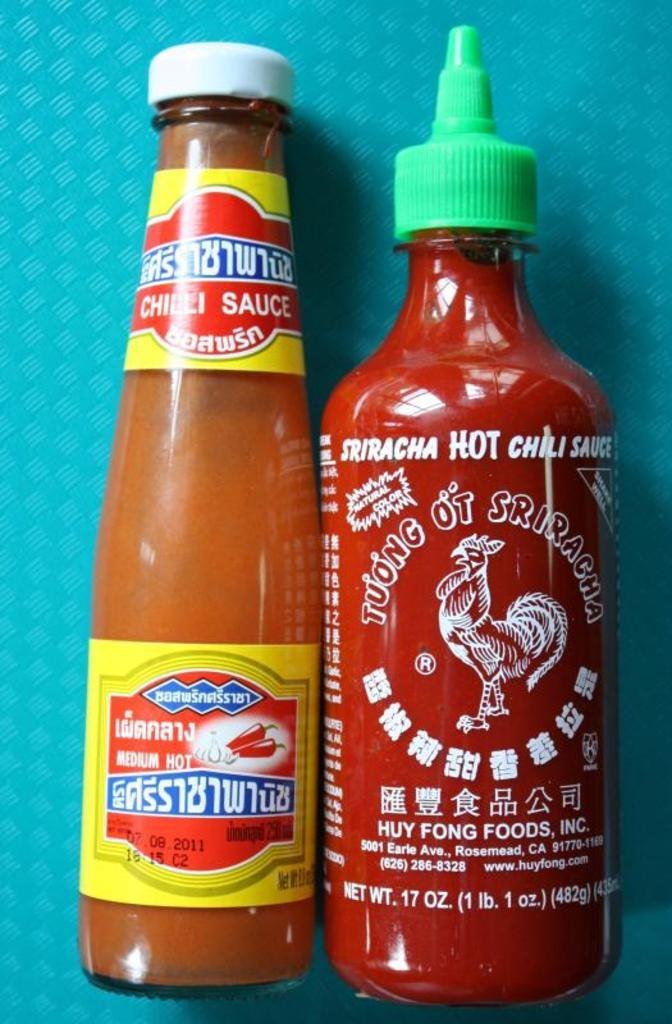<image>
Render a clear and concise summary of the photo. Two bottle of hot sauce on a blue mat background. 